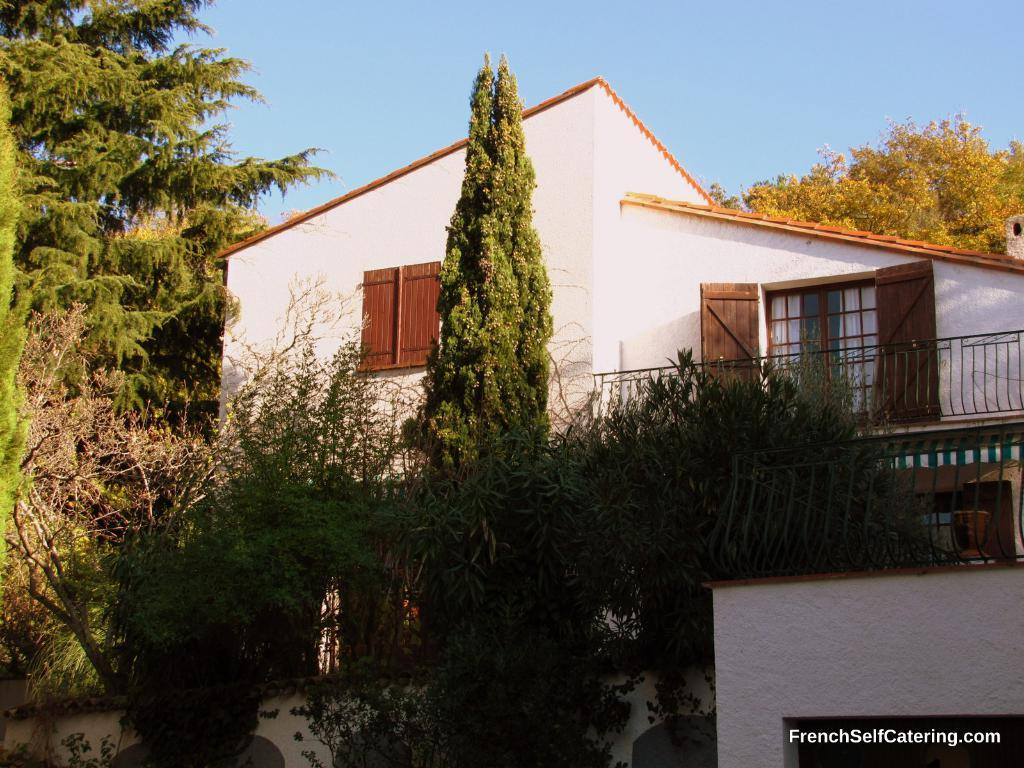What type of structure is present in the image? There is a house in the image. What are some features of the house? The house has walls, a door, grills, and windows. Are there any natural elements in the image? Yes, there are trees in the image. What can be seen in the background of the image? The sky is visible in the background of the image. Is there any text present in the image? Yes, there is some text on the right side, bottom of the image. How many elbows can be seen on the giants in the image? There are no giants or elbows present in the image; it features a house with various architectural features and natural elements. What type of donkey is depicted in the image? There is no donkey present in the image. 